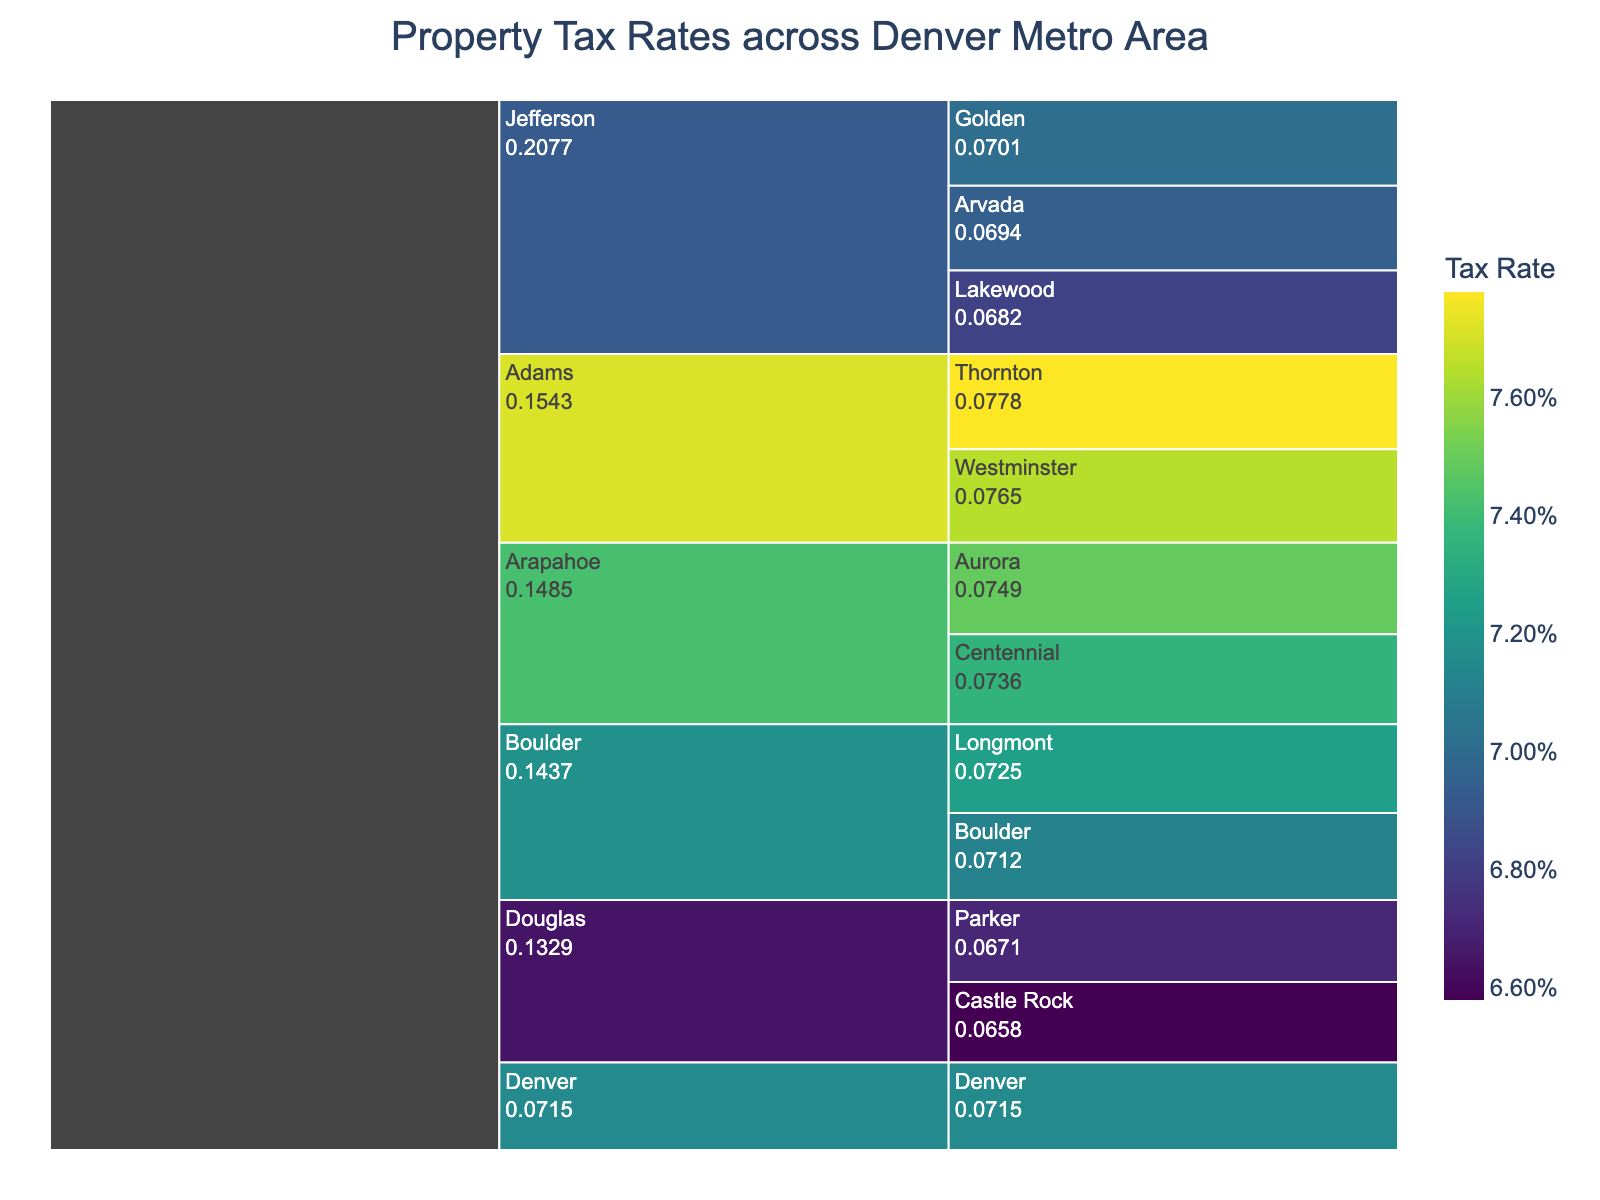What is the title of the chart? The title is displayed at the top of the chart.
Answer: Property Tax Rates across Denver Metro Area Which municipality in the Adams county has the higher tax rate? Look at the municipalities under Adams county and compare their tax rates.
Answer: Thornton List all the counties with at least two municipalities represented in the chart. Identify counties with more than one municipality.
Answer: Jefferson, Arapahoe, Adams, Boulder Which municipality has the highest property tax rate? Check the values for all municipalities and identify the highest one.
Answer: Thornton Compare the property tax rate of Golden to Lakewood in Jefferson county. Examine and contrast the tax rates for Golden and Lakewood.
Answer: Golden's tax rate is higher What is the average property tax rate in Arapahoe county? Add the tax rates for Aurora and Centennial and divide by the number of municipalities. (0.0749 + 0.0736) / 2 = 0.07425
Answer: 0.07425 How much higher is the tax rate in Boulder than in Castle Rock? Subtract the tax rate of Castle Rock from the tax rate of Boulder. (0.0712 - 0.0658) = 0.0054
Answer: 0.0054 Which county has the lowest average property tax rate? Calculate and compare the average tax rates of all counties. Douglas has the lowest average rate with (0.0658 + 0.0671) / 2 = 0.06645.
Answer: Douglas Which municipality in Jefferson county has the lowest tax rate? Identify and compare the tax rates for all municipalities in Jefferson county.
Answer: Lakewood How does the property tax rate in Parker compare to the overall average tax rate in the chart? Calculate the overall average tax rate and compare it with Parker's tax rate. Average rate is 0.0706. Parker's rate (0.0671) is lower.
Answer: Lower 